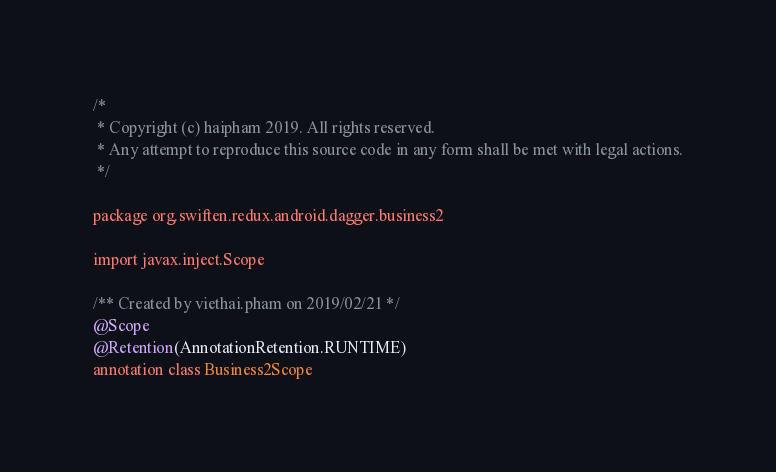Convert code to text. <code><loc_0><loc_0><loc_500><loc_500><_Kotlin_>/*
 * Copyright (c) haipham 2019. All rights reserved.
 * Any attempt to reproduce this source code in any form shall be met with legal actions.
 */

package org.swiften.redux.android.dagger.business2

import javax.inject.Scope

/** Created by viethai.pham on 2019/02/21 */
@Scope
@Retention(AnnotationRetention.RUNTIME)
annotation class Business2Scope
</code> 